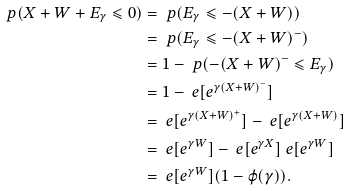Convert formula to latex. <formula><loc_0><loc_0><loc_500><loc_500>\ p ( X + W + E _ { \gamma } \leqslant 0 ) & = \ p ( E _ { \gamma } \leqslant - ( X + W ) ) \\ & = \ p ( E _ { \gamma } \leqslant - ( X + W ) ^ { - } ) \\ & = 1 - \ p ( - ( X + W ) ^ { - } \leqslant E _ { \gamma } ) \\ & = 1 - \ e [ e ^ { \gamma ( X + W ) ^ { - } } ] \\ & = \ e [ e ^ { \gamma ( X + W ) ^ { + } } ] - \ e [ e ^ { \gamma ( X + W ) } ] \\ & = \ e [ e ^ { \gamma W } ] - \ e [ e ^ { \gamma X } ] \ e [ e ^ { \gamma W } ] \\ & = \ e [ e ^ { \gamma W } ] ( 1 - \varphi ( \gamma ) ) .</formula> 